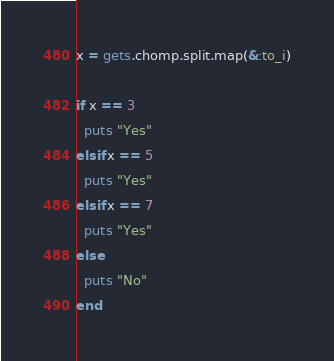Convert code to text. <code><loc_0><loc_0><loc_500><loc_500><_Ruby_>x = gets.chomp.split.map(&:to_i)

if x == 3
  puts "Yes"
elsif x == 5
  puts "Yes"
elsif x == 7
  puts "Yes"
else
  puts "No"
end</code> 